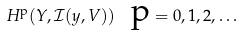Convert formula to latex. <formula><loc_0><loc_0><loc_500><loc_500>H ^ { \text {p} } ( Y , \mathcal { I ( } y , V ) ) \text { \ p} = 0 , 1 , 2 , \dots</formula> 